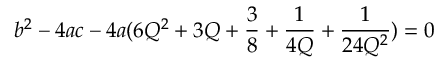<formula> <loc_0><loc_0><loc_500><loc_500>b ^ { 2 } - 4 a c - 4 a ( 6 Q ^ { 2 } + 3 Q + \frac { 3 } { 8 } + \frac { 1 } { 4 Q } + \frac { 1 } { 2 4 Q ^ { 2 } } ) = 0</formula> 